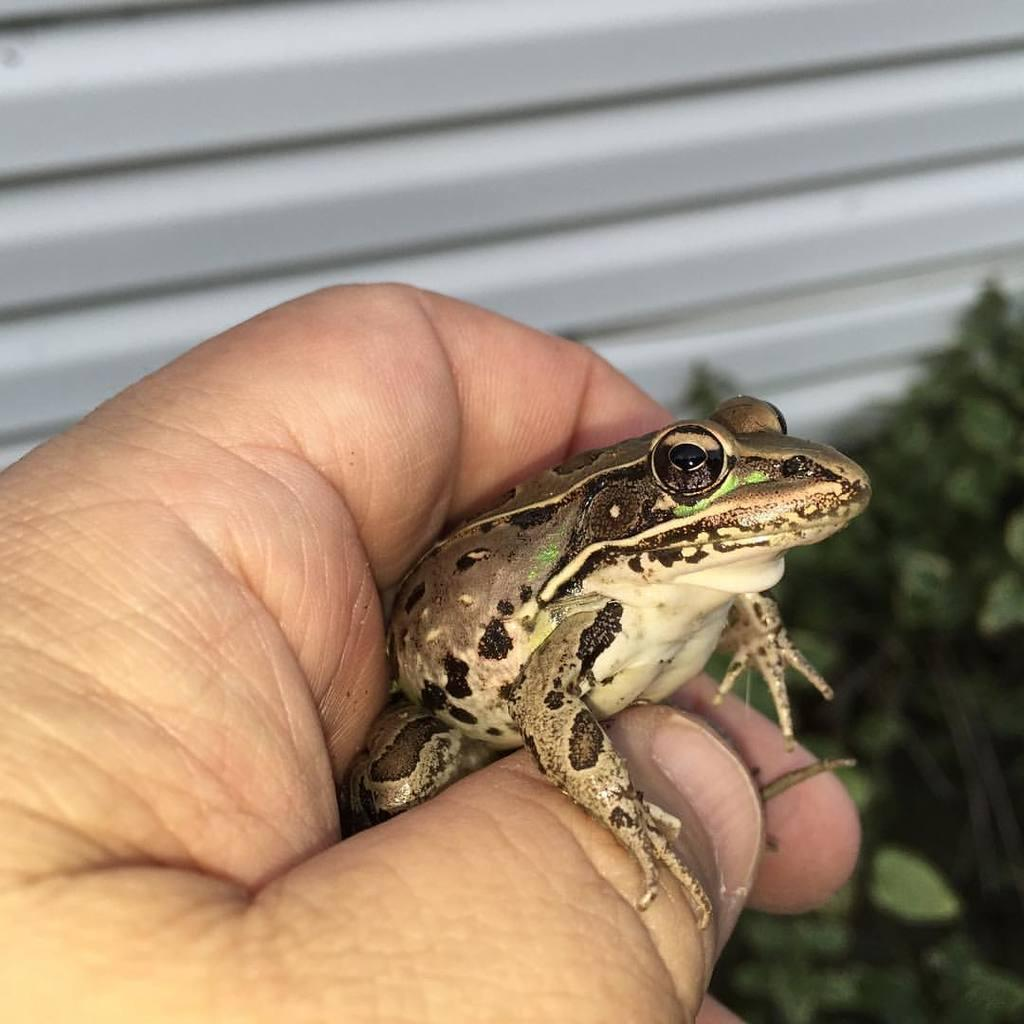What part of the human body is visible in the image? There is a human hand in the image. What type of animal is present in the image? There is a frog in the image. What type of vegetation is present in the image? There is a plant in the image. What type of secretary can be seen in the image? There is no secretary present in the image. How many kittens are playing with the frog in the image? There are no kittens present in the image, and the frog is not shown playing with any animals. 